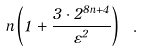<formula> <loc_0><loc_0><loc_500><loc_500>n \left ( 1 + \frac { 3 \cdot 2 ^ { 8 n + 4 } } { \varepsilon ^ { 2 } } \right ) \ .</formula> 